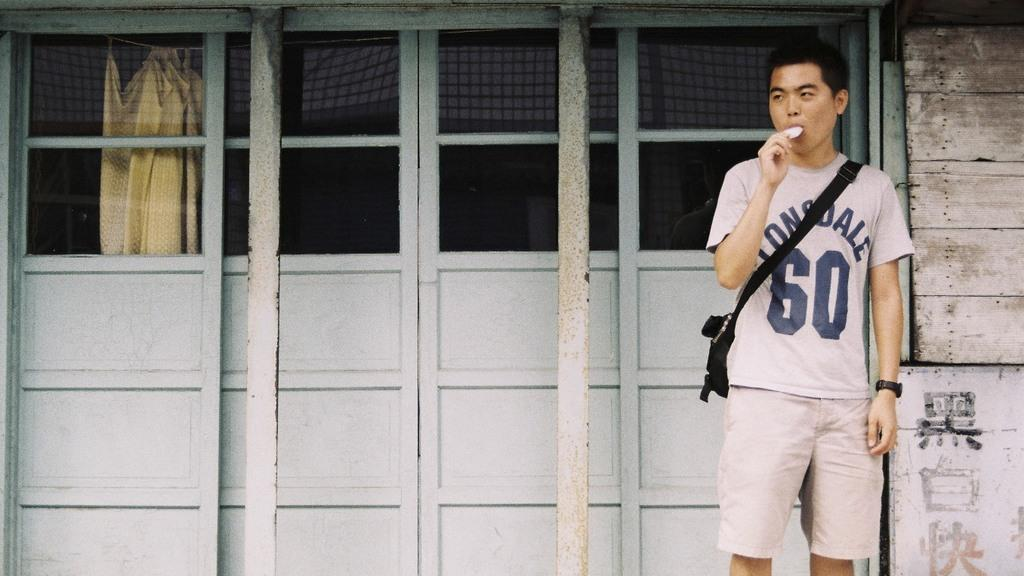<image>
Write a terse but informative summary of the picture. A teenage Asian boy with the number 60 on the front of his shirt, is standing in front of a garage door, eating. 